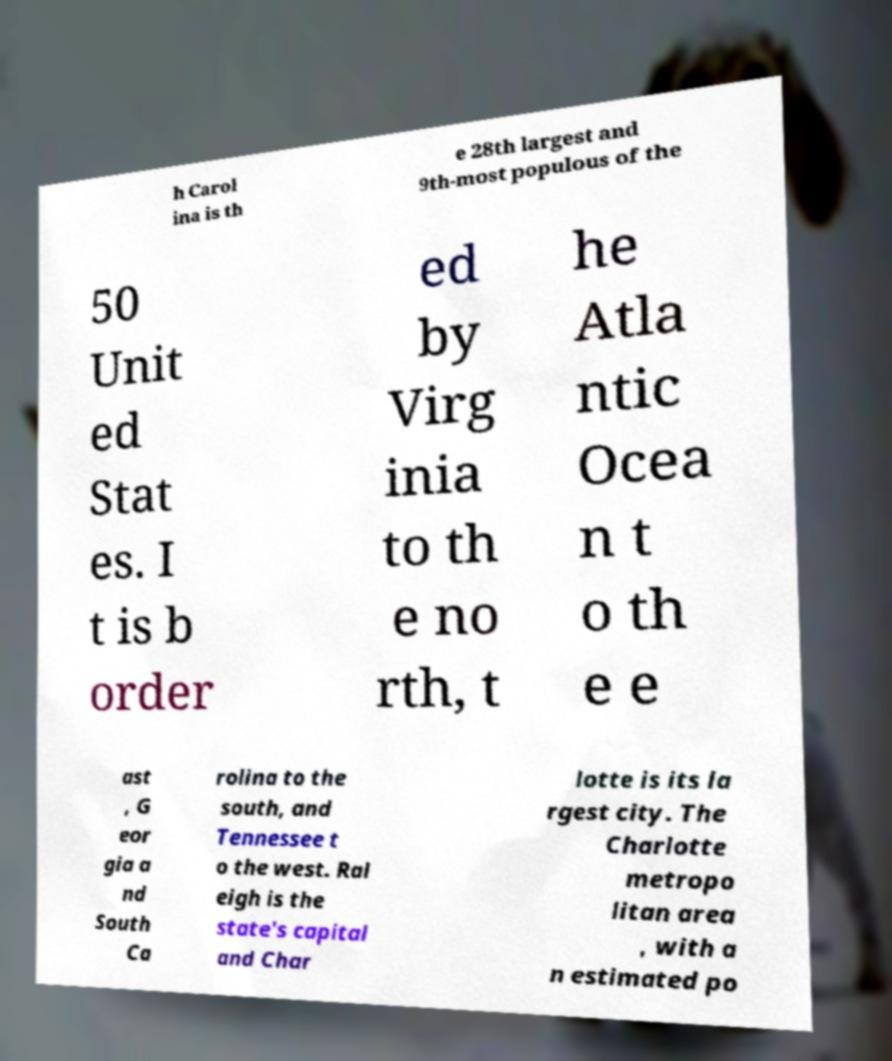Can you accurately transcribe the text from the provided image for me? h Carol ina is th e 28th largest and 9th-most populous of the 50 Unit ed Stat es. I t is b order ed by Virg inia to th e no rth, t he Atla ntic Ocea n t o th e e ast , G eor gia a nd South Ca rolina to the south, and Tennessee t o the west. Ral eigh is the state's capital and Char lotte is its la rgest city. The Charlotte metropo litan area , with a n estimated po 